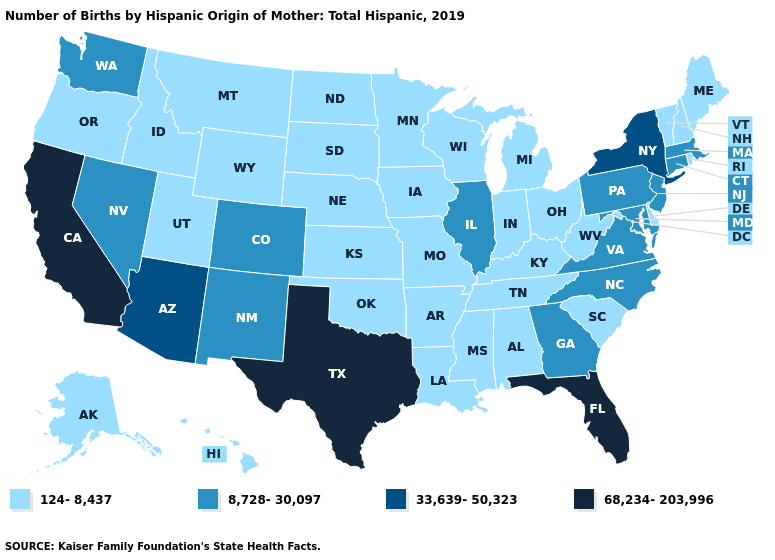Does the first symbol in the legend represent the smallest category?
Quick response, please. Yes. Which states hav the highest value in the South?
Be succinct. Florida, Texas. What is the value of Tennessee?
Concise answer only. 124-8,437. What is the value of Vermont?
Concise answer only. 124-8,437. Does Mississippi have the highest value in the USA?
Short answer required. No. What is the lowest value in states that border Florida?
Be succinct. 124-8,437. What is the value of West Virginia?
Concise answer only. 124-8,437. How many symbols are there in the legend?
Answer briefly. 4. What is the value of Maine?
Give a very brief answer. 124-8,437. Name the states that have a value in the range 33,639-50,323?
Give a very brief answer. Arizona, New York. What is the lowest value in states that border Oregon?
Short answer required. 124-8,437. Does Georgia have a higher value than New Jersey?
Answer briefly. No. Which states have the highest value in the USA?
Concise answer only. California, Florida, Texas. What is the highest value in states that border Kansas?
Write a very short answer. 8,728-30,097. Name the states that have a value in the range 68,234-203,996?
Answer briefly. California, Florida, Texas. 